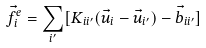<formula> <loc_0><loc_0><loc_500><loc_500>\vec { f } ^ { e } _ { i } = \sum _ { i ^ { \prime } } [ { K } _ { i i ^ { \prime } } ( \vec { u } _ { i } - \vec { u } _ { i ^ { \prime } } ) - \vec { b } _ { i i ^ { \prime } } ]</formula> 